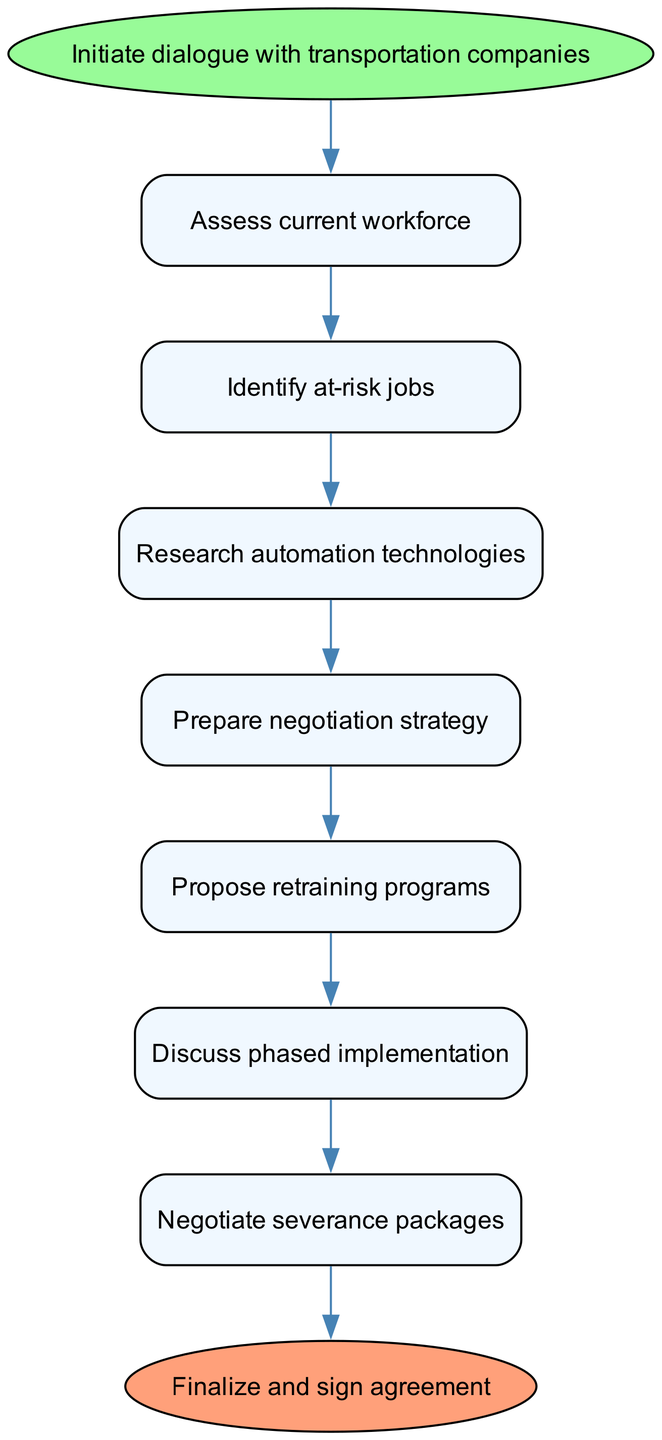What is the first action in the negotiation process? The diagram indicates that the first action is "Initiate dialogue with transportation companies," which is noted in the start node.
Answer: Initiate dialogue with transportation companies How many steps are involved in the negotiation process? By counting the steps listed in the flow chart, there are a total of 7 steps before the finalization.
Answer: 7 What action comes after "Propose retraining programs"? According to the flowchart, the action that follows "Propose retraining programs" is "Discuss phased implementation," which directly connects in the sequence.
Answer: Discuss phased implementation What is the last action before finalizing the agreement? The final step before reaching the end node is "Draft agreement," which is the last action in the chain leading to the conclusion of the process.
Answer: Draft agreement Which step comes immediately after "Research automation technologies"? The diagram shows that the immediate next action after "Research automation technologies" is "Prepare negotiation strategy," thus establishing a direct flow between these two actions.
Answer: Prepare negotiation strategy What is the color of the start node? The start node in the diagram is indicated to have a fill color of light green, highlighted in the diagram for the beginning of the process.
Answer: Light green How does "Negotiate severance packages" relate to the other steps? "Negotiate severance packages" is positioned towards the end of the sequence, indicating that it follows a series of preparatory actions, specifically after "Discuss phased implementation." The relation is sequential in the negotiation process.
Answer: Sequentially before drafting agreement What is the outcome of the negotiation process? The outcome is defined in the diagram as "Finalize and sign agreement," which signifies the completion of the negotiation efforts after all steps are undertaken.
Answer: Finalize and sign agreement 